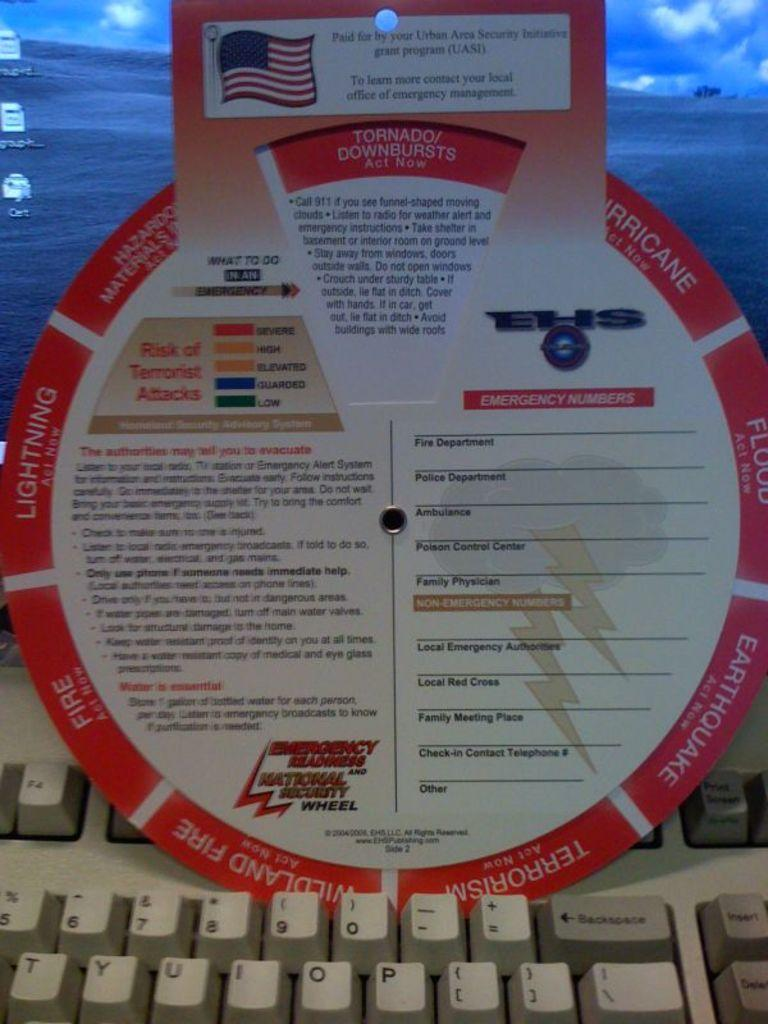<image>
Offer a succinct explanation of the picture presented. A sign lists information available by the Urban Area Security Initiative. 